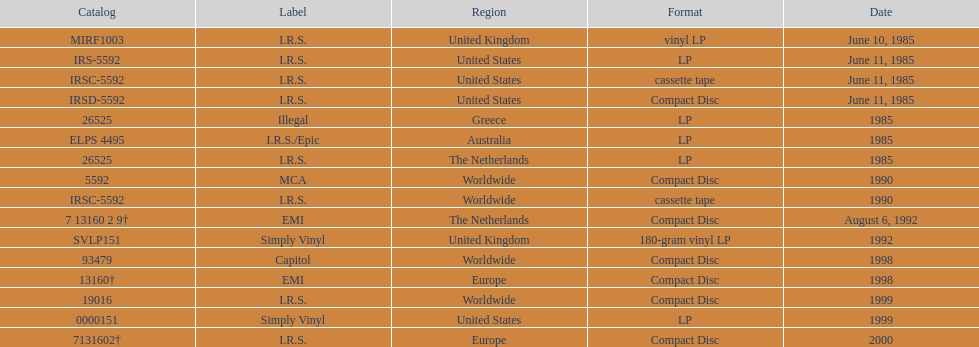Which region has more than one format? United States. 